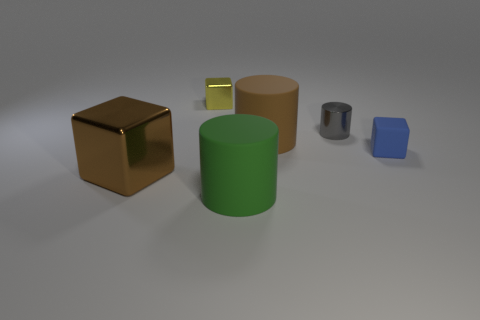What number of objects are behind the big metal cube and to the left of the blue matte thing?
Offer a very short reply. 3. What is the material of the large brown object behind the tiny thing in front of the brown cylinder?
Keep it short and to the point. Rubber. Are there any objects that have the same material as the gray cylinder?
Keep it short and to the point. Yes. There is a blue thing that is the same size as the gray object; what is its material?
Keep it short and to the point. Rubber. What is the size of the matte cylinder that is in front of the block in front of the block on the right side of the yellow thing?
Your answer should be compact. Large. There is a object behind the small metallic cylinder; is there a small cube that is on the right side of it?
Provide a short and direct response. Yes. There is a brown rubber thing; is its shape the same as the small blue thing right of the yellow object?
Give a very brief answer. No. The big matte cylinder that is in front of the tiny matte block is what color?
Your response must be concise. Green. What is the size of the shiny cube behind the metal thing in front of the gray object?
Provide a short and direct response. Small. There is a brown object that is in front of the blue rubber object; is it the same shape as the big green object?
Your answer should be very brief. No. 